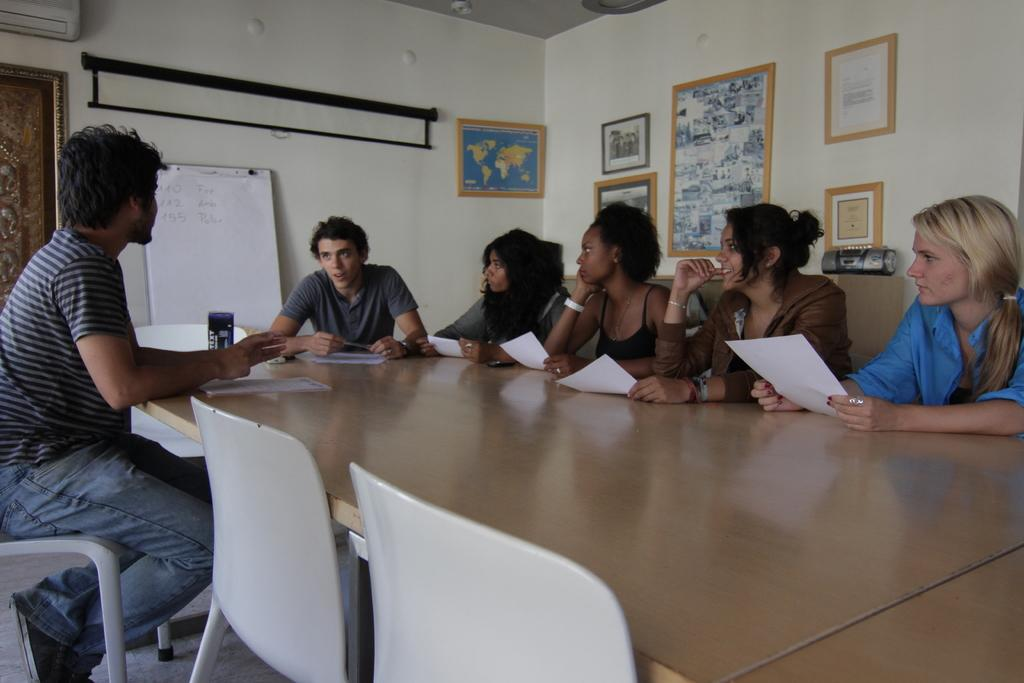What type of structure can be seen in the image? There is a wall in the image. What is hanging on the wall? There are photo frames in the image. What is located near the wall? There is a board in the image. What are the people in the image doing? There are people sitting on chairs in the image. What is on the table in the image? There is a table in the image, and there are papers on the table. What invention is being demonstrated by the rabbit in the image? There is no rabbit present in the image, and therefore no invention can be demonstrated. What mark can be seen on the board in the image? There is no mark visible on the board in the image. 